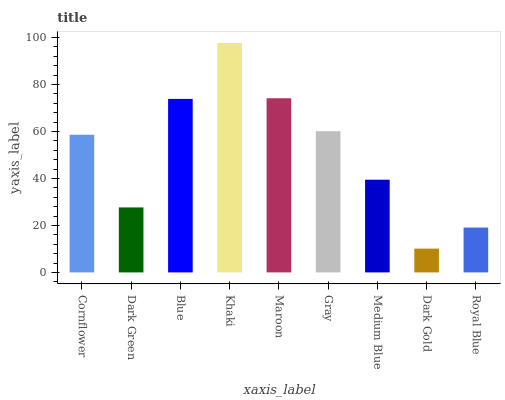Is Dark Gold the minimum?
Answer yes or no. Yes. Is Khaki the maximum?
Answer yes or no. Yes. Is Dark Green the minimum?
Answer yes or no. No. Is Dark Green the maximum?
Answer yes or no. No. Is Cornflower greater than Dark Green?
Answer yes or no. Yes. Is Dark Green less than Cornflower?
Answer yes or no. Yes. Is Dark Green greater than Cornflower?
Answer yes or no. No. Is Cornflower less than Dark Green?
Answer yes or no. No. Is Cornflower the high median?
Answer yes or no. Yes. Is Cornflower the low median?
Answer yes or no. Yes. Is Gray the high median?
Answer yes or no. No. Is Khaki the low median?
Answer yes or no. No. 